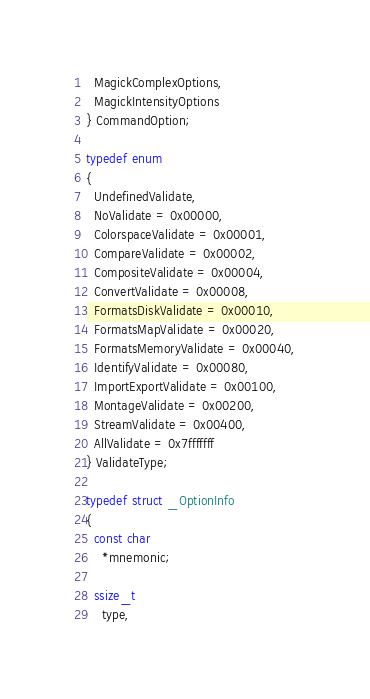Convert code to text. <code><loc_0><loc_0><loc_500><loc_500><_C_>  MagickComplexOptions,
  MagickIntensityOptions
} CommandOption;

typedef enum
{
  UndefinedValidate,
  NoValidate = 0x00000,
  ColorspaceValidate = 0x00001,
  CompareValidate = 0x00002,
  CompositeValidate = 0x00004,
  ConvertValidate = 0x00008,
  FormatsDiskValidate = 0x00010,
  FormatsMapValidate = 0x00020,
  FormatsMemoryValidate = 0x00040,
  IdentifyValidate = 0x00080,
  ImportExportValidate = 0x00100,
  MontageValidate = 0x00200,
  StreamValidate = 0x00400,
  AllValidate = 0x7fffffff
} ValidateType;

typedef struct _OptionInfo
{
  const char
    *mnemonic;

  ssize_t
    type,</code> 